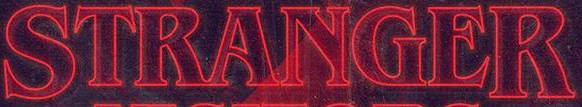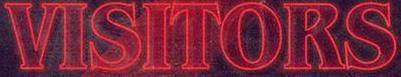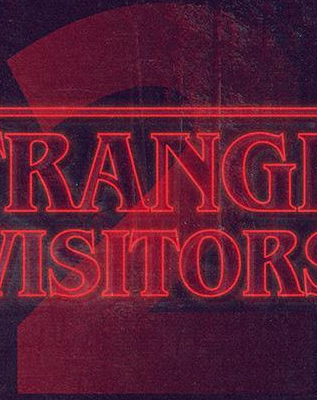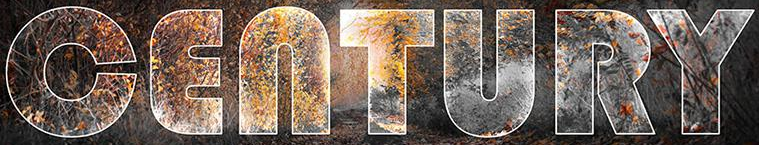What words are shown in these images in order, separated by a semicolon? STRANGER; VISITORS; 2; CENTURY 